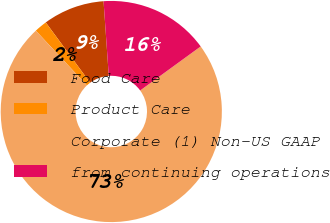Convert chart to OTSL. <chart><loc_0><loc_0><loc_500><loc_500><pie_chart><fcel>Food Care<fcel>Product Care<fcel>Corporate (1) Non-US GAAP<fcel>from continuing operations<nl><fcel>8.98%<fcel>1.86%<fcel>73.06%<fcel>16.1%<nl></chart> 